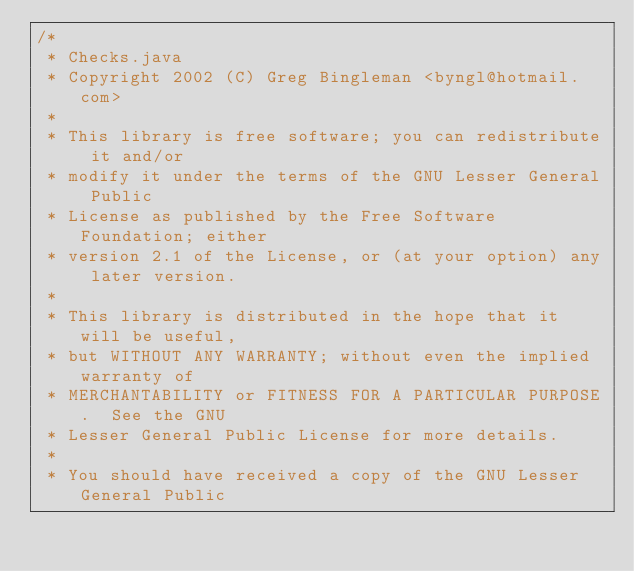<code> <loc_0><loc_0><loc_500><loc_500><_Java_>/*
 * Checks.java
 * Copyright 2002 (C) Greg Bingleman <byngl@hotmail.com>
 *
 * This library is free software; you can redistribute it and/or
 * modify it under the terms of the GNU Lesser General Public
 * License as published by the Free Software Foundation; either
 * version 2.1 of the License, or (at your option) any later version.
 *
 * This library is distributed in the hope that it will be useful,
 * but WITHOUT ANY WARRANTY; without even the implied warranty of
 * MERCHANTABILITY or FITNESS FOR A PARTICULAR PURPOSE.  See the GNU
 * Lesser General Public License for more details.
 *
 * You should have received a copy of the GNU Lesser General Public</code> 